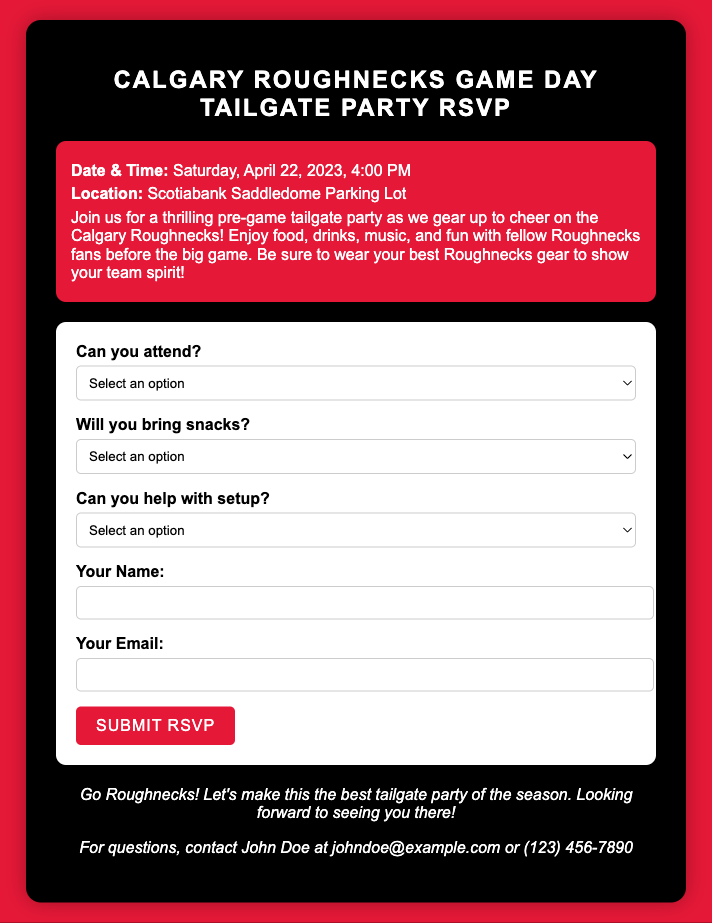What is the date of the tailgate party? The date of the tailgate party is mentioned in the document as Saturday, April 22, 2023.
Answer: Saturday, April 22, 2023 What location is specified for the event? The document states that the location for the tailgate party is the Scotiabank Saddledome Parking Lot.
Answer: Scotiabank Saddledome Parking Lot What color is the background of the RSVP card? The background color of the RSVP card is specified in the style section as #E51837.
Answer: #E51837 What is the email address for questions? The document provides an email address for questions which is johndoe@example.com.
Answer: johndoe@example.com Can attendees bring snacks? The RSVP form includes a question about bringing snacks with options such as 'I'd love to bring some snacks!' and 'I won't be able to bring snacks.'
Answer: Yes or No What time does the tailgate party start? The document states that the tailgate party starts at 4:00 PM.
Answer: 4:00 PM Who can help with setting up the event? The RSVP form has an option for attendees to indicate if they can help with setup, phrased as 'I'll help with setting up before the party!' or 'I won't be able to help with setting up.'
Answer: Yes or No What should guests wear to show team spirit? The document encourages attendees to wear their best Roughnecks gear.
Answer: Best Roughnecks gear What is the significance of the RSVP card? The RSVP card allows attendees to confirm their attendance and participation in the tailgate activities such as bringing snacks and helping set up.
Answer: Confirmation of attendance and participation 